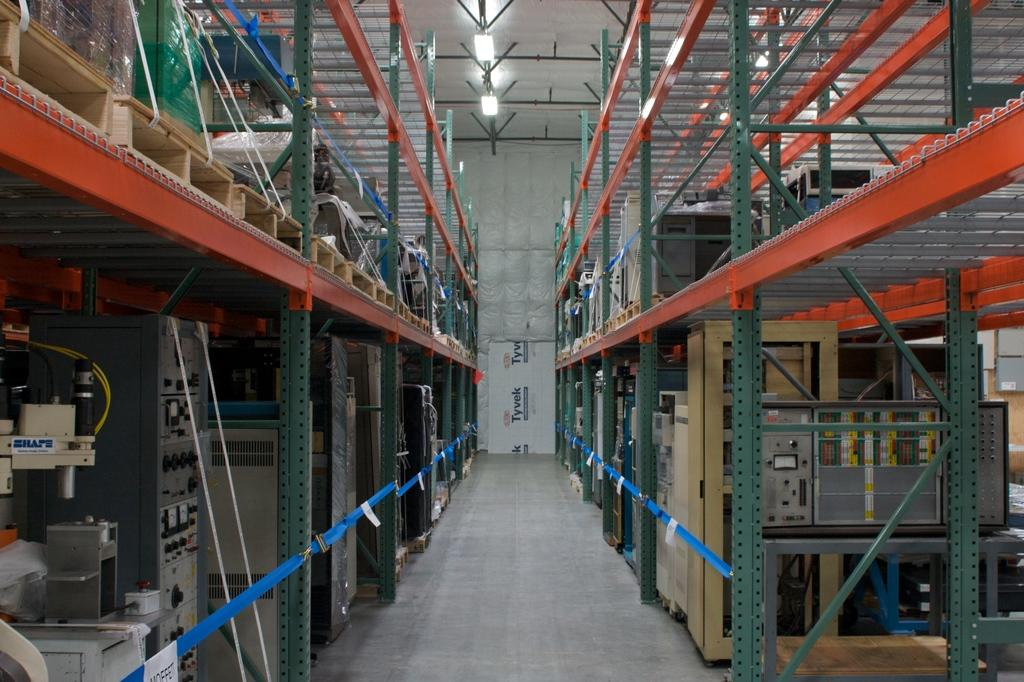What type of objects can be seen in the image? There are machines and metal rods present in the image. Can you describe the unspecified things in the image? Unfortunately, the provided facts do not specify what these unspecified things are. What can be seen in the background of the image? Lights are visible in the background of the image. How many eggs are being used in the war depicted in the image? There is no war or eggs present in the image; it features machines and metal rods. What type of marble is being played on the table in the image? There is no table or marble game present in the image. 